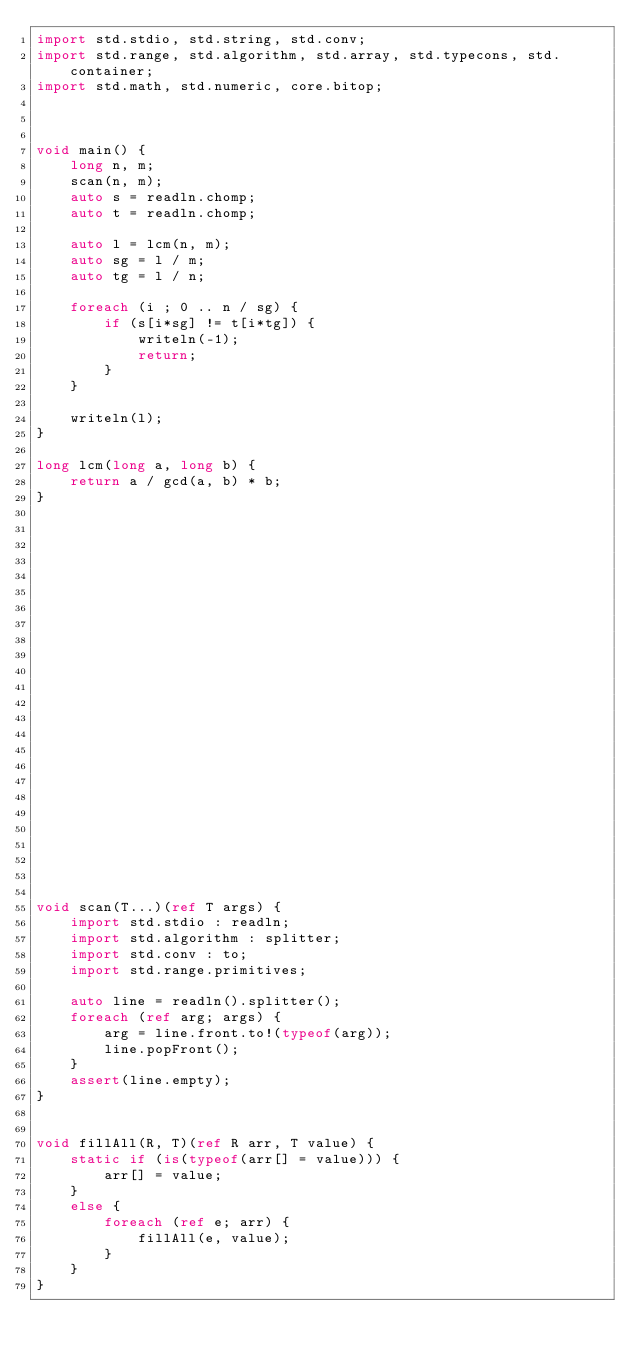Convert code to text. <code><loc_0><loc_0><loc_500><loc_500><_D_>import std.stdio, std.string, std.conv;
import std.range, std.algorithm, std.array, std.typecons, std.container;
import std.math, std.numeric, core.bitop;



void main() {
    long n, m;
    scan(n, m);
    auto s = readln.chomp;
    auto t = readln.chomp;

    auto l = lcm(n, m);
    auto sg = l / m;
    auto tg = l / n;

    foreach (i ; 0 .. n / sg) {
        if (s[i*sg] != t[i*tg]) {
            writeln(-1);
            return;
        }
    }

    writeln(l);
}

long lcm(long a, long b) {
    return a / gcd(a, b) * b;
}

























void scan(T...)(ref T args) {
    import std.stdio : readln;
    import std.algorithm : splitter;
    import std.conv : to;
    import std.range.primitives;

    auto line = readln().splitter();
    foreach (ref arg; args) {
        arg = line.front.to!(typeof(arg));
        line.popFront();
    }
    assert(line.empty);
}


void fillAll(R, T)(ref R arr, T value) {
    static if (is(typeof(arr[] = value))) {
        arr[] = value;
    }
    else {
        foreach (ref e; arr) {
            fillAll(e, value);
        }
    }
}</code> 